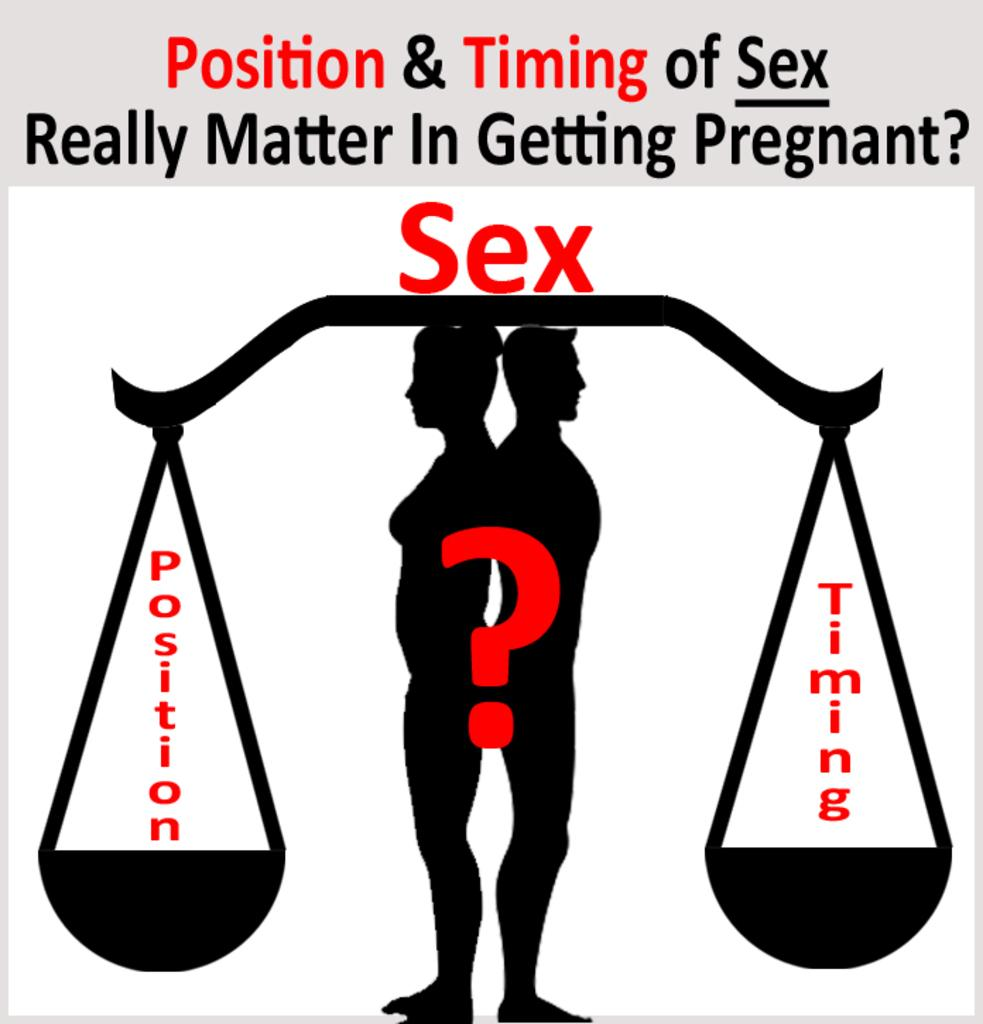Provide a one-sentence caption for the provided image. A graphic bringing up the question of position and timing during sex. 